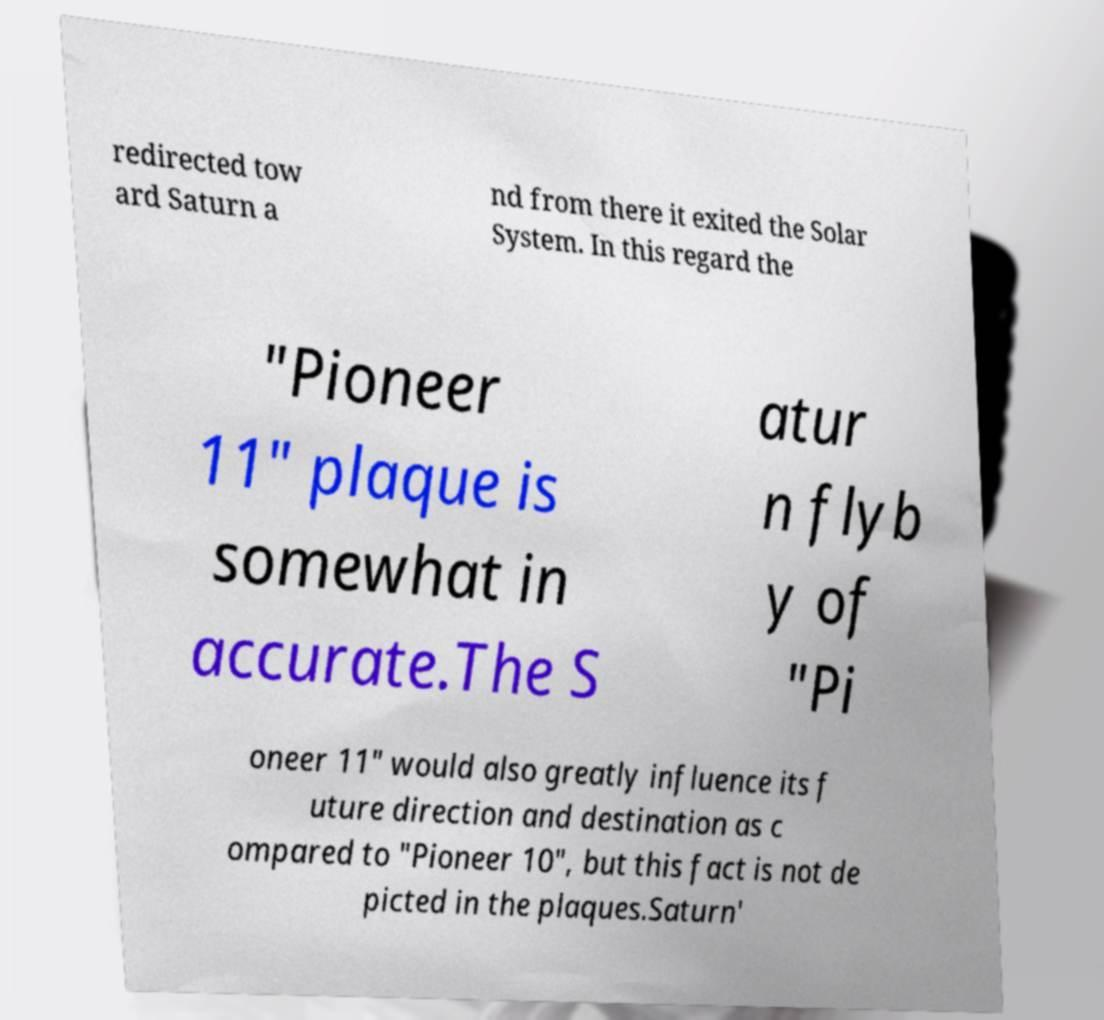Please identify and transcribe the text found in this image. redirected tow ard Saturn a nd from there it exited the Solar System. In this regard the "Pioneer 11" plaque is somewhat in accurate.The S atur n flyb y of "Pi oneer 11" would also greatly influence its f uture direction and destination as c ompared to "Pioneer 10", but this fact is not de picted in the plaques.Saturn' 